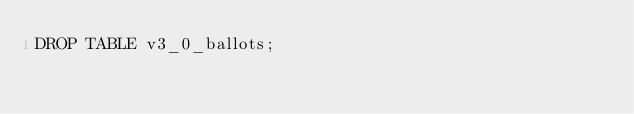Convert code to text. <code><loc_0><loc_0><loc_500><loc_500><_SQL_>DROP TABLE v3_0_ballots;
</code> 